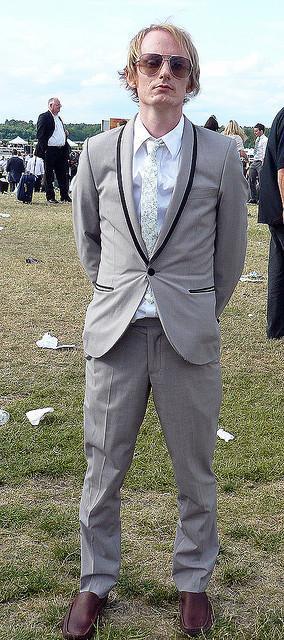How many people are in the photo?
Give a very brief answer. 3. 